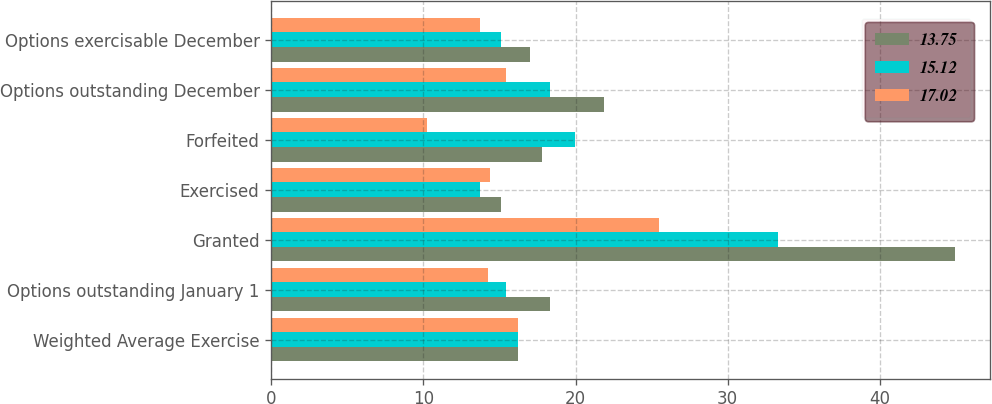<chart> <loc_0><loc_0><loc_500><loc_500><stacked_bar_chart><ecel><fcel>Weighted Average Exercise<fcel>Options outstanding January 1<fcel>Granted<fcel>Exercised<fcel>Forfeited<fcel>Options outstanding December<fcel>Options exercisable December<nl><fcel>13.75<fcel>16.23<fcel>18.32<fcel>44.96<fcel>15.1<fcel>17.81<fcel>21.89<fcel>17.02<nl><fcel>15.12<fcel>16.23<fcel>15.44<fcel>33.3<fcel>13.69<fcel>19.95<fcel>18.32<fcel>15.12<nl><fcel>17.02<fcel>16.23<fcel>14.22<fcel>25.46<fcel>14.41<fcel>10.26<fcel>15.44<fcel>13.75<nl></chart> 